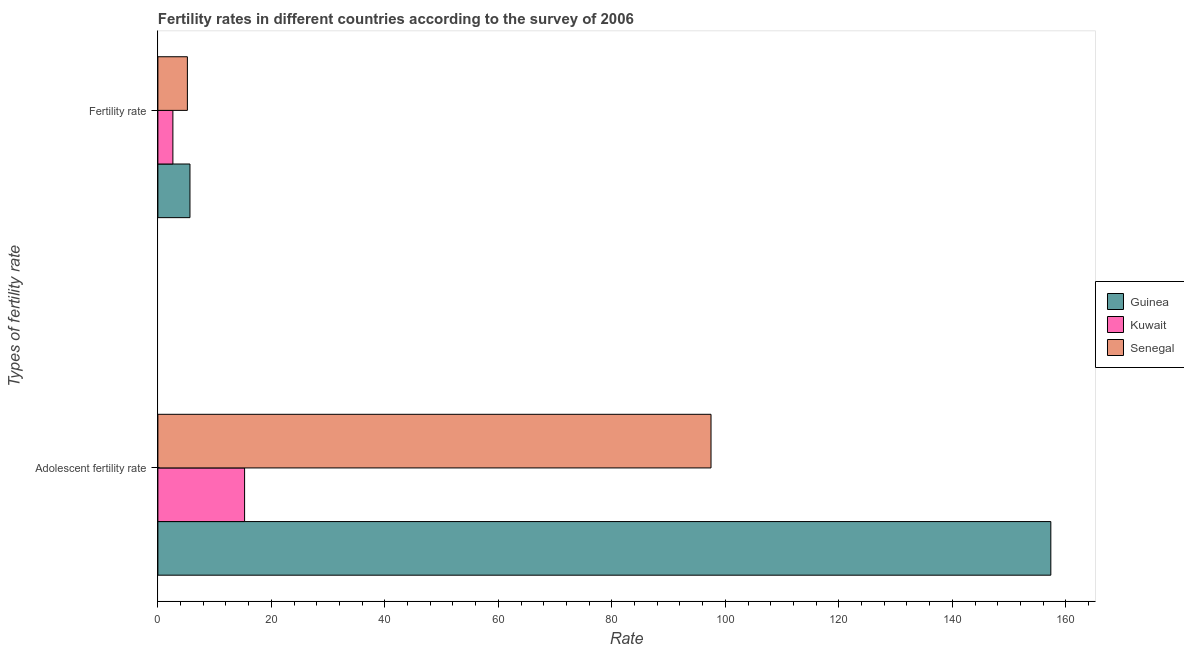How many groups of bars are there?
Offer a very short reply. 2. Are the number of bars on each tick of the Y-axis equal?
Your answer should be very brief. Yes. How many bars are there on the 2nd tick from the top?
Your answer should be compact. 3. What is the label of the 2nd group of bars from the top?
Your response must be concise. Adolescent fertility rate. What is the adolescent fertility rate in Senegal?
Provide a short and direct response. 97.48. Across all countries, what is the maximum adolescent fertility rate?
Your response must be concise. 157.36. Across all countries, what is the minimum adolescent fertility rate?
Ensure brevity in your answer.  15.28. In which country was the fertility rate maximum?
Give a very brief answer. Guinea. In which country was the adolescent fertility rate minimum?
Offer a very short reply. Kuwait. What is the total fertility rate in the graph?
Give a very brief answer. 13.5. What is the difference between the adolescent fertility rate in Guinea and that in Senegal?
Make the answer very short. 59.88. What is the difference between the adolescent fertility rate in Kuwait and the fertility rate in Guinea?
Make the answer very short. 9.63. What is the average adolescent fertility rate per country?
Your answer should be very brief. 90.04. What is the difference between the fertility rate and adolescent fertility rate in Kuwait?
Provide a succinct answer. -12.63. What is the ratio of the adolescent fertility rate in Kuwait to that in Guinea?
Your answer should be compact. 0.1. In how many countries, is the adolescent fertility rate greater than the average adolescent fertility rate taken over all countries?
Provide a short and direct response. 2. What does the 3rd bar from the top in Fertility rate represents?
Your answer should be compact. Guinea. What does the 1st bar from the bottom in Fertility rate represents?
Your response must be concise. Guinea. What is the difference between two consecutive major ticks on the X-axis?
Your answer should be compact. 20. Does the graph contain grids?
Offer a very short reply. No. Where does the legend appear in the graph?
Offer a terse response. Center right. How are the legend labels stacked?
Your response must be concise. Vertical. What is the title of the graph?
Provide a short and direct response. Fertility rates in different countries according to the survey of 2006. What is the label or title of the X-axis?
Make the answer very short. Rate. What is the label or title of the Y-axis?
Your response must be concise. Types of fertility rate. What is the Rate of Guinea in Adolescent fertility rate?
Provide a succinct answer. 157.36. What is the Rate in Kuwait in Adolescent fertility rate?
Offer a very short reply. 15.28. What is the Rate of Senegal in Adolescent fertility rate?
Provide a short and direct response. 97.48. What is the Rate in Guinea in Fertility rate?
Provide a succinct answer. 5.65. What is the Rate in Kuwait in Fertility rate?
Your answer should be very brief. 2.65. What is the Rate in Senegal in Fertility rate?
Your response must be concise. 5.2. Across all Types of fertility rate, what is the maximum Rate in Guinea?
Ensure brevity in your answer.  157.36. Across all Types of fertility rate, what is the maximum Rate of Kuwait?
Ensure brevity in your answer.  15.28. Across all Types of fertility rate, what is the maximum Rate in Senegal?
Your answer should be compact. 97.48. Across all Types of fertility rate, what is the minimum Rate of Guinea?
Your response must be concise. 5.65. Across all Types of fertility rate, what is the minimum Rate in Kuwait?
Your answer should be compact. 2.65. Across all Types of fertility rate, what is the minimum Rate of Senegal?
Offer a very short reply. 5.2. What is the total Rate in Guinea in the graph?
Make the answer very short. 163.01. What is the total Rate in Kuwait in the graph?
Offer a very short reply. 17.92. What is the total Rate in Senegal in the graph?
Offer a very short reply. 102.67. What is the difference between the Rate in Guinea in Adolescent fertility rate and that in Fertility rate?
Your answer should be compact. 151.71. What is the difference between the Rate in Kuwait in Adolescent fertility rate and that in Fertility rate?
Provide a short and direct response. 12.63. What is the difference between the Rate of Senegal in Adolescent fertility rate and that in Fertility rate?
Make the answer very short. 92.28. What is the difference between the Rate of Guinea in Adolescent fertility rate and the Rate of Kuwait in Fertility rate?
Provide a succinct answer. 154.72. What is the difference between the Rate in Guinea in Adolescent fertility rate and the Rate in Senegal in Fertility rate?
Offer a terse response. 152.16. What is the difference between the Rate of Kuwait in Adolescent fertility rate and the Rate of Senegal in Fertility rate?
Ensure brevity in your answer.  10.08. What is the average Rate of Guinea per Types of fertility rate?
Offer a very short reply. 81.51. What is the average Rate in Kuwait per Types of fertility rate?
Make the answer very short. 8.96. What is the average Rate in Senegal per Types of fertility rate?
Provide a succinct answer. 51.34. What is the difference between the Rate in Guinea and Rate in Kuwait in Adolescent fertility rate?
Offer a terse response. 142.08. What is the difference between the Rate in Guinea and Rate in Senegal in Adolescent fertility rate?
Your answer should be compact. 59.88. What is the difference between the Rate of Kuwait and Rate of Senegal in Adolescent fertility rate?
Your response must be concise. -82.2. What is the difference between the Rate in Guinea and Rate in Kuwait in Fertility rate?
Provide a short and direct response. 3.01. What is the difference between the Rate in Guinea and Rate in Senegal in Fertility rate?
Offer a terse response. 0.46. What is the difference between the Rate in Kuwait and Rate in Senegal in Fertility rate?
Your response must be concise. -2.55. What is the ratio of the Rate in Guinea in Adolescent fertility rate to that in Fertility rate?
Provide a short and direct response. 27.84. What is the ratio of the Rate in Kuwait in Adolescent fertility rate to that in Fertility rate?
Offer a very short reply. 5.78. What is the ratio of the Rate of Senegal in Adolescent fertility rate to that in Fertility rate?
Make the answer very short. 18.75. What is the difference between the highest and the second highest Rate in Guinea?
Give a very brief answer. 151.71. What is the difference between the highest and the second highest Rate in Kuwait?
Make the answer very short. 12.63. What is the difference between the highest and the second highest Rate of Senegal?
Provide a succinct answer. 92.28. What is the difference between the highest and the lowest Rate of Guinea?
Give a very brief answer. 151.71. What is the difference between the highest and the lowest Rate in Kuwait?
Keep it short and to the point. 12.63. What is the difference between the highest and the lowest Rate in Senegal?
Offer a very short reply. 92.28. 